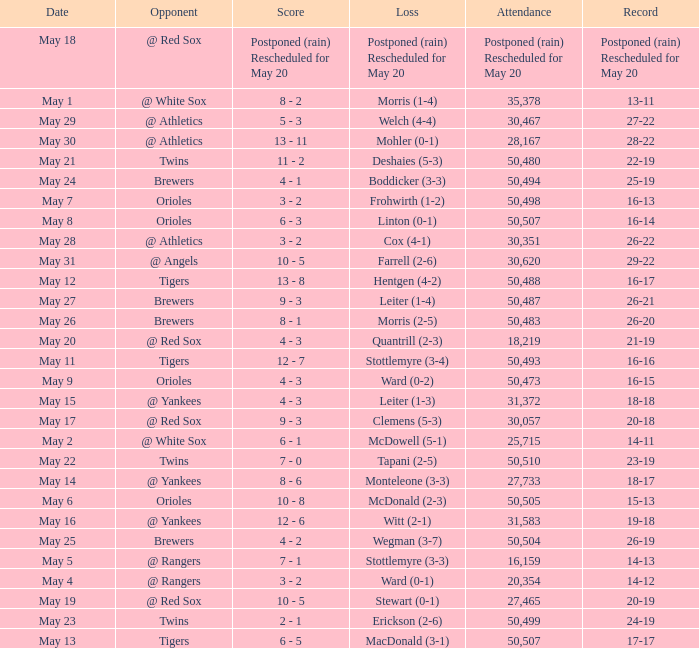What was the score of the game played on May 9? 4 - 3. 